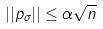<formula> <loc_0><loc_0><loc_500><loc_500>| | p _ { \sigma } | | \leq \alpha \sqrt { n }</formula> 